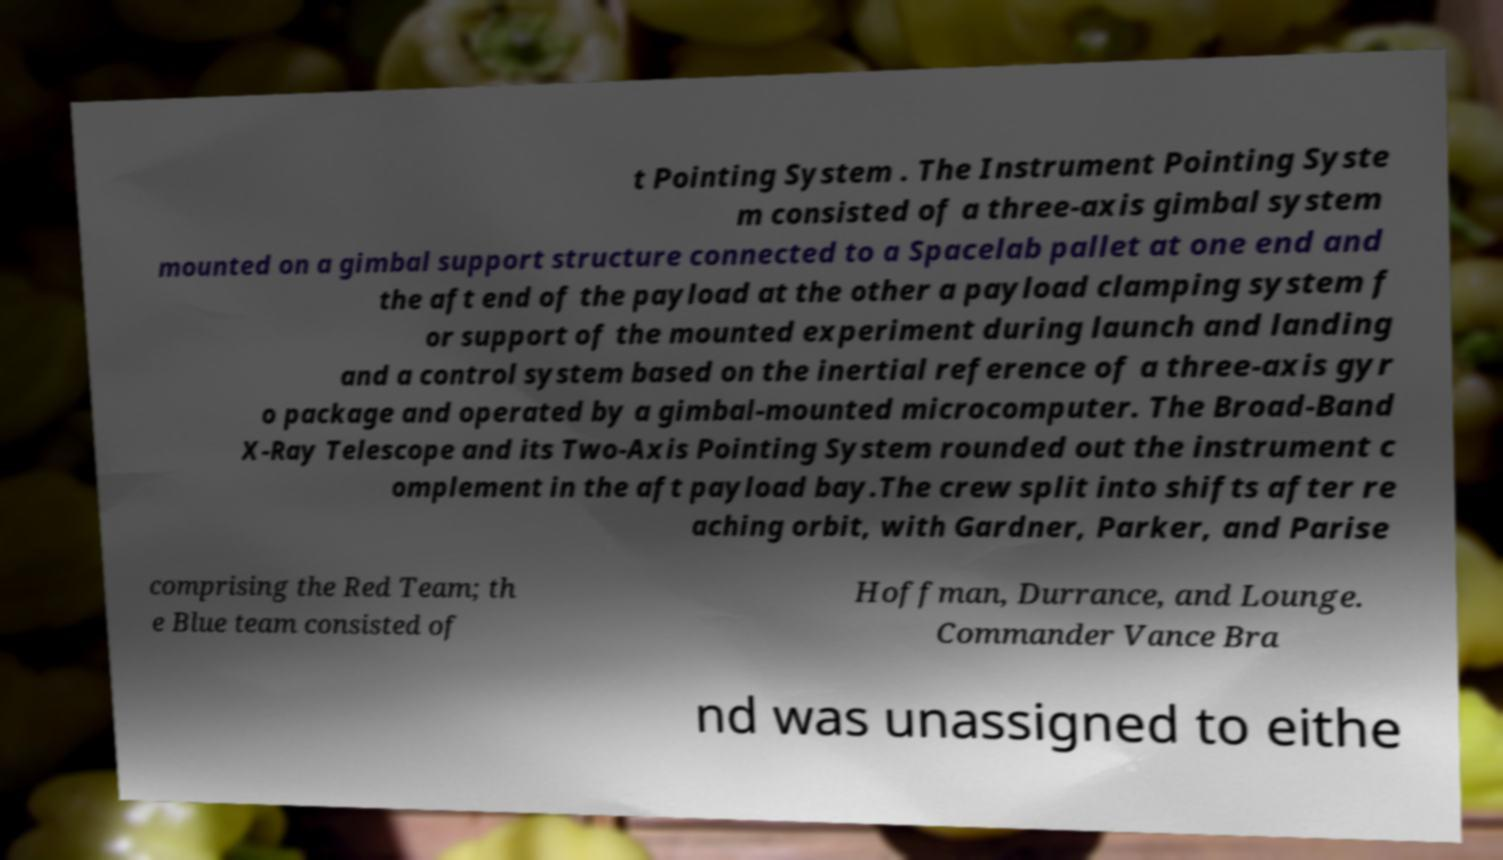For documentation purposes, I need the text within this image transcribed. Could you provide that? t Pointing System . The Instrument Pointing Syste m consisted of a three-axis gimbal system mounted on a gimbal support structure connected to a Spacelab pallet at one end and the aft end of the payload at the other a payload clamping system f or support of the mounted experiment during launch and landing and a control system based on the inertial reference of a three-axis gyr o package and operated by a gimbal-mounted microcomputer. The Broad-Band X-Ray Telescope and its Two-Axis Pointing System rounded out the instrument c omplement in the aft payload bay.The crew split into shifts after re aching orbit, with Gardner, Parker, and Parise comprising the Red Team; th e Blue team consisted of Hoffman, Durrance, and Lounge. Commander Vance Bra nd was unassigned to eithe 